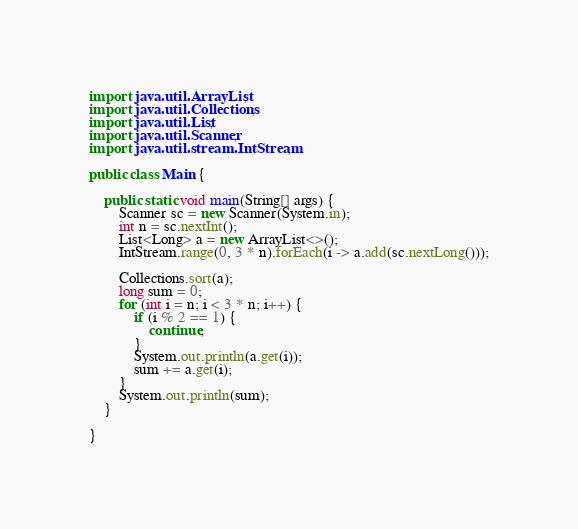<code> <loc_0><loc_0><loc_500><loc_500><_Java_>import java.util.ArrayList;
import java.util.Collections;
import java.util.List;
import java.util.Scanner;
import java.util.stream.IntStream;

public class Main {

    public static void main(String[] args) {
        Scanner sc = new Scanner(System.in);
        int n = sc.nextInt();
        List<Long> a = new ArrayList<>();
        IntStream.range(0, 3 * n).forEach(i -> a.add(sc.nextLong()));

        Collections.sort(a);
        long sum = 0;
        for (int i = n; i < 3 * n; i++) {
            if (i % 2 == 1) {
                continue;
            }
            System.out.println(a.get(i));
            sum += a.get(i);
        }
        System.out.println(sum);
    }

}
</code> 